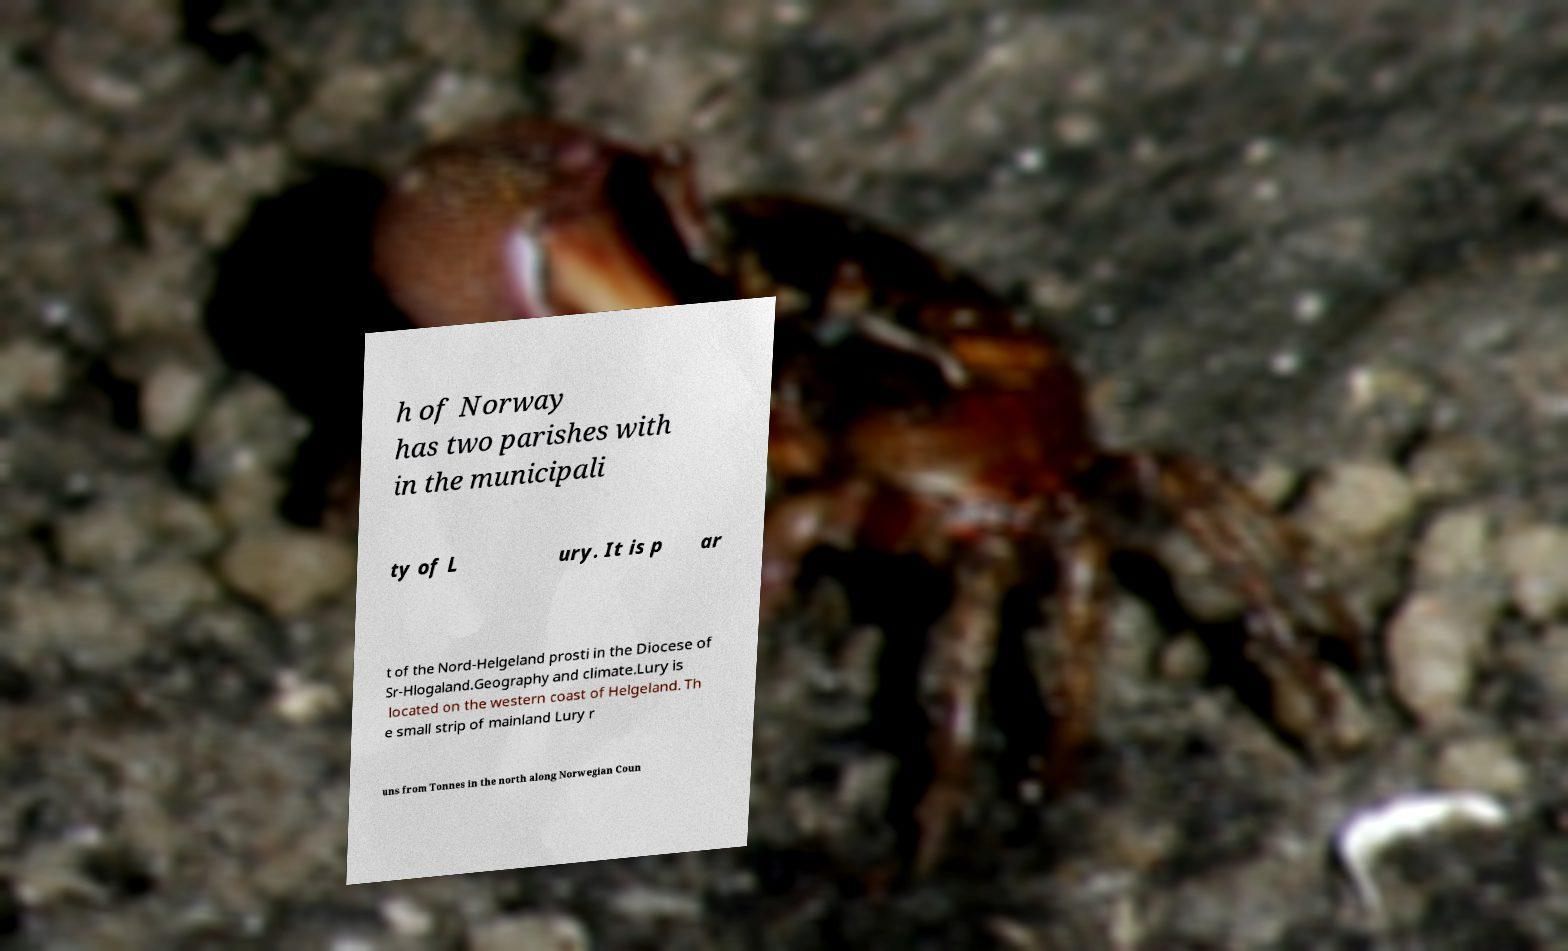For documentation purposes, I need the text within this image transcribed. Could you provide that? h of Norway has two parishes with in the municipali ty of L ury. It is p ar t of the Nord-Helgeland prosti in the Diocese of Sr-Hlogaland.Geography and climate.Lury is located on the western coast of Helgeland. Th e small strip of mainland Lury r uns from Tonnes in the north along Norwegian Coun 